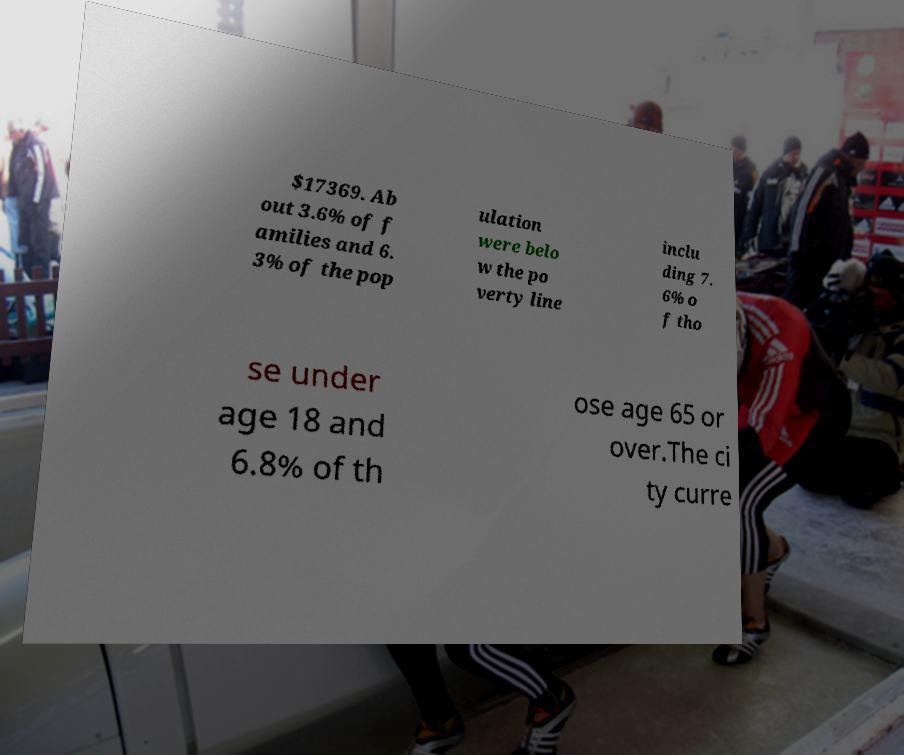There's text embedded in this image that I need extracted. Can you transcribe it verbatim? $17369. Ab out 3.6% of f amilies and 6. 3% of the pop ulation were belo w the po verty line inclu ding 7. 6% o f tho se under age 18 and 6.8% of th ose age 65 or over.The ci ty curre 